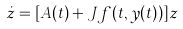<formula> <loc_0><loc_0><loc_500><loc_500>\dot { z } = [ A ( t ) + J f ( t , y ( t ) ) ] z</formula> 